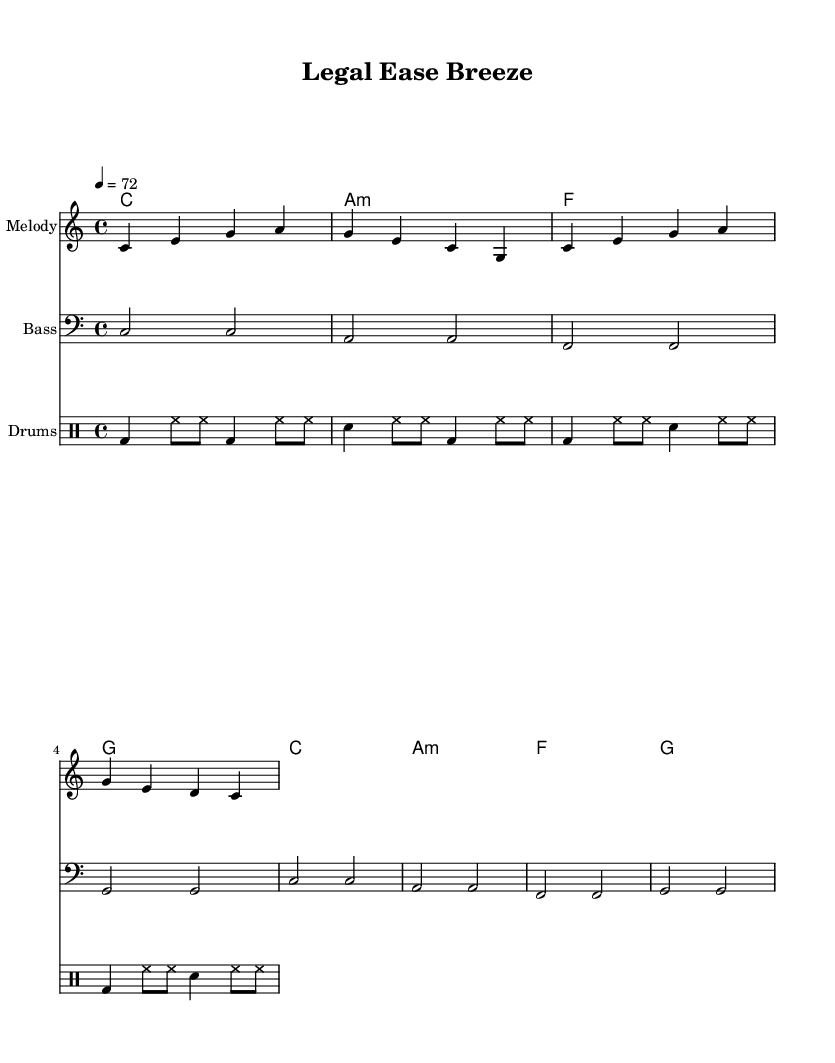What is the key signature of this music? The key signature is C major, which has no sharps or flats.
Answer: C major What is the time signature of this music? The time signature is located at the beginning of the score, indicating how many beats are in each measure, which is 4 beats per measure.
Answer: 4/4 What is the tempo marking for this piece? The tempo marking is found at the start and indicates a speed of 72 beats per minute.
Answer: 72 How many measures are in the melody section? By counting the measures in the melody part, we see there are 4 distinct measures.
Answer: 4 What type of musical form is primarily used in this piece? The piece uses a repetitive structure common in reggae, defined by the repeated chord progression and melody; this indicates a strophic or verse-chorus form.
Answer: Strophic What is the instrument name for the drumming part? The drum part is indicated with "Drums" at the top of the staff, signaling the instrument used in this section.
Answer: Drums What chords are used in the chord progression? The chords listed in the chordNames part are analyzed to show that they include C, A minor, F, and G, which are typical in reggae music.
Answer: C, A minor, F, G 